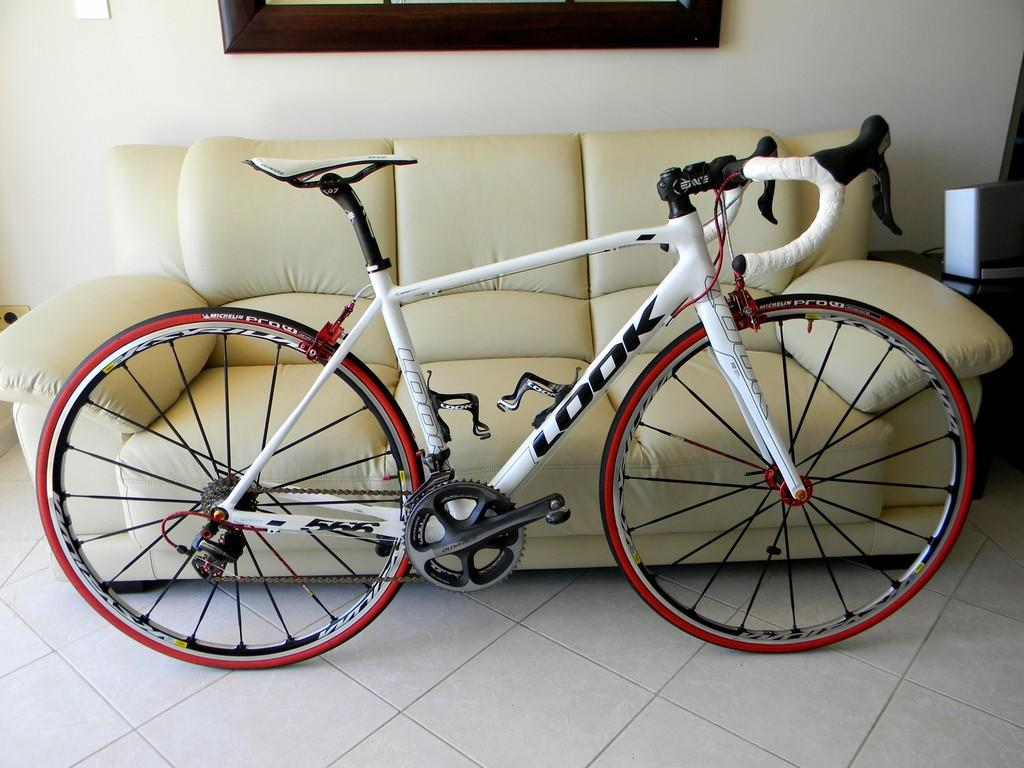What is the main object in the image? There is a bicycle in the image. What colors can be seen on the bicycle? The bicycle is in white and red colors. What type of furniture is present in the image? There is a couch in the image. What color is the couch? The couch is in cream color. What can be seen in the background of the image? There is a wall in the background of the image. What type of trousers is the dad wearing in the image? There is no dad or trousers present in the image; it only features a bicycle, a couch, and a wall. 